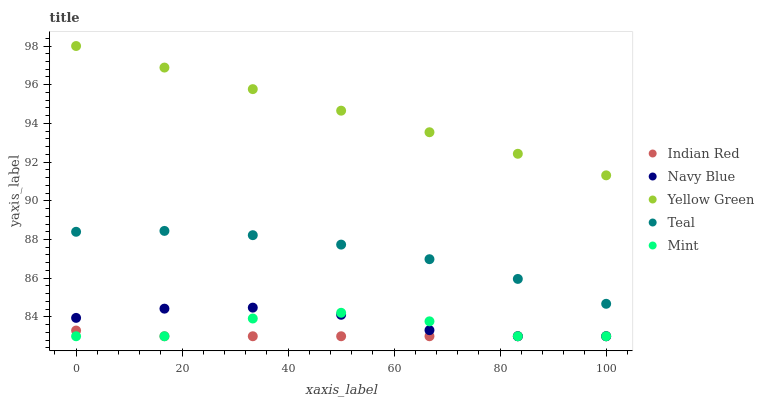Does Indian Red have the minimum area under the curve?
Answer yes or no. Yes. Does Yellow Green have the maximum area under the curve?
Answer yes or no. Yes. Does Navy Blue have the minimum area under the curve?
Answer yes or no. No. Does Navy Blue have the maximum area under the curve?
Answer yes or no. No. Is Yellow Green the smoothest?
Answer yes or no. Yes. Is Mint the roughest?
Answer yes or no. Yes. Is Navy Blue the smoothest?
Answer yes or no. No. Is Navy Blue the roughest?
Answer yes or no. No. Does Navy Blue have the lowest value?
Answer yes or no. Yes. Does Yellow Green have the lowest value?
Answer yes or no. No. Does Yellow Green have the highest value?
Answer yes or no. Yes. Does Navy Blue have the highest value?
Answer yes or no. No. Is Teal less than Yellow Green?
Answer yes or no. Yes. Is Teal greater than Mint?
Answer yes or no. Yes. Does Indian Red intersect Mint?
Answer yes or no. Yes. Is Indian Red less than Mint?
Answer yes or no. No. Is Indian Red greater than Mint?
Answer yes or no. No. Does Teal intersect Yellow Green?
Answer yes or no. No. 